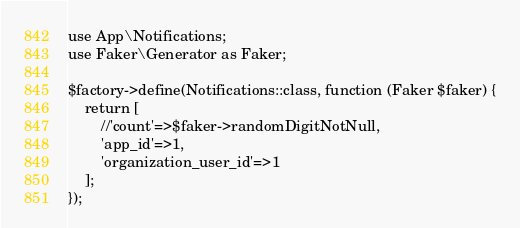Convert code to text. <code><loc_0><loc_0><loc_500><loc_500><_PHP_>use App\Notifications;
use Faker\Generator as Faker;

$factory->define(Notifications::class, function (Faker $faker) {
    return [
        //'count'=>$faker->randomDigitNotNull,
        'app_id'=>1,
        'organization_user_id'=>1
    ];
});
</code> 